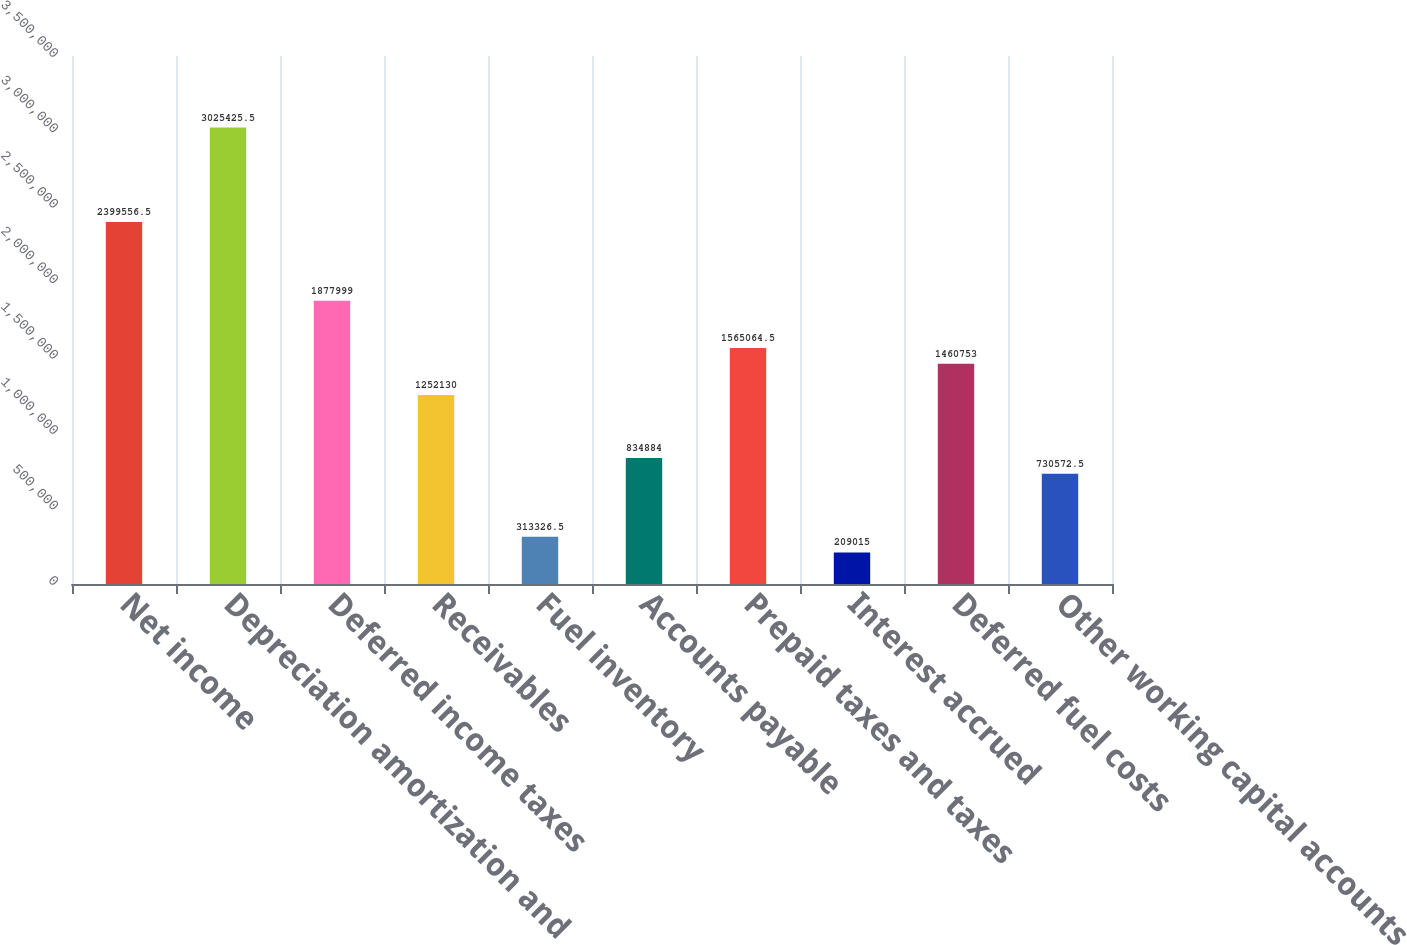<chart> <loc_0><loc_0><loc_500><loc_500><bar_chart><fcel>Net income<fcel>Depreciation amortization and<fcel>Deferred income taxes<fcel>Receivables<fcel>Fuel inventory<fcel>Accounts payable<fcel>Prepaid taxes and taxes<fcel>Interest accrued<fcel>Deferred fuel costs<fcel>Other working capital accounts<nl><fcel>2.39956e+06<fcel>3.02543e+06<fcel>1.878e+06<fcel>1.25213e+06<fcel>313326<fcel>834884<fcel>1.56506e+06<fcel>209015<fcel>1.46075e+06<fcel>730572<nl></chart> 